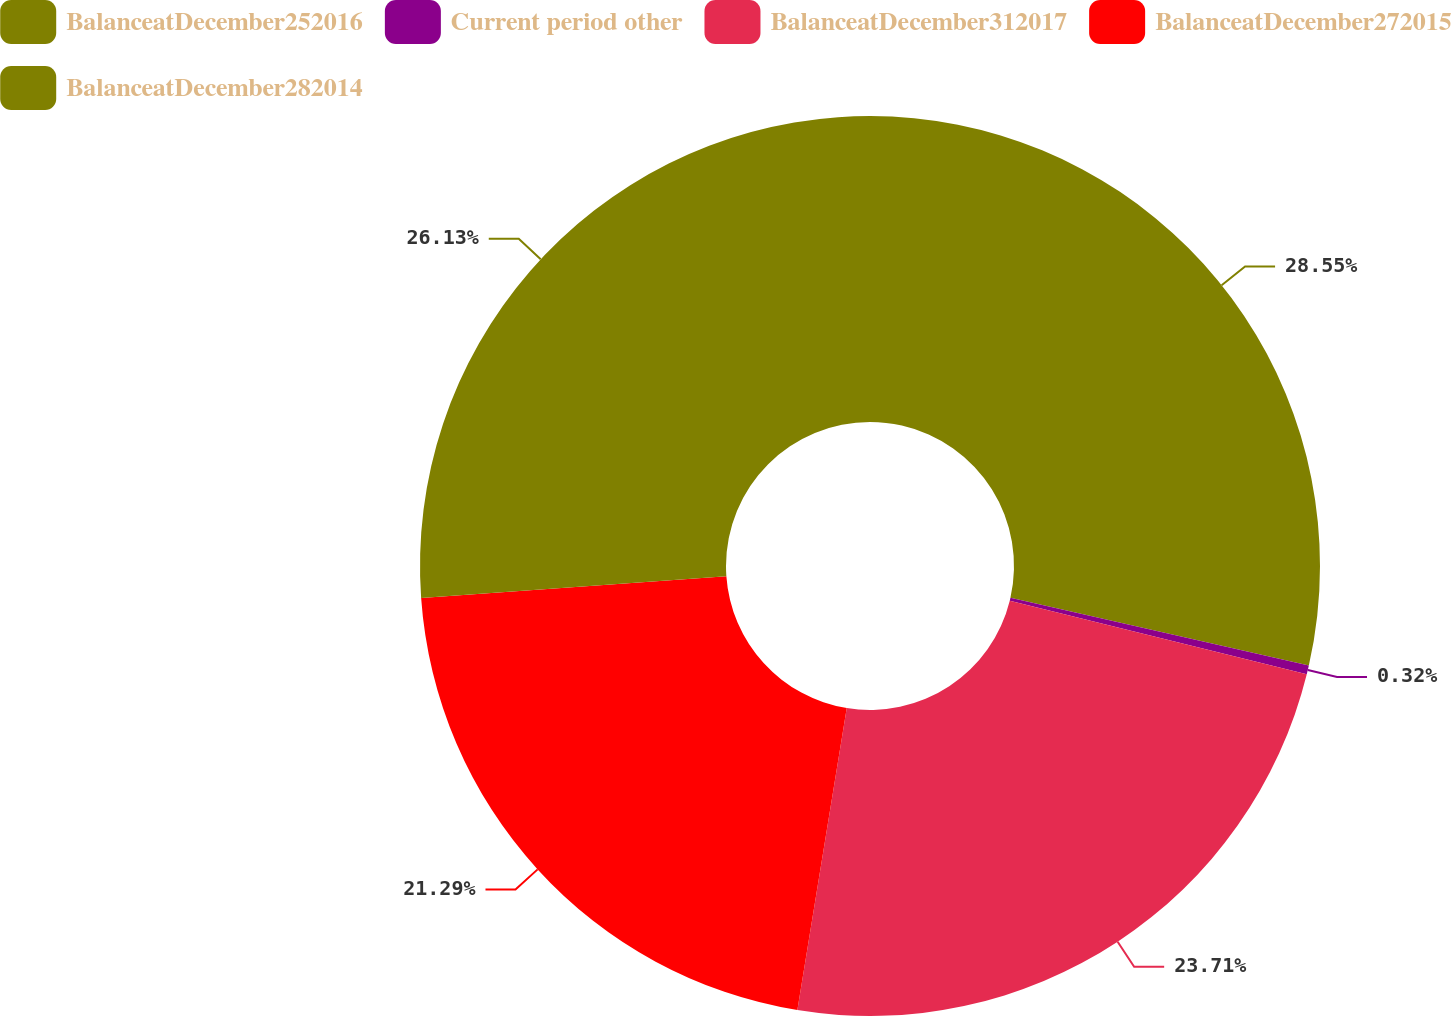Convert chart. <chart><loc_0><loc_0><loc_500><loc_500><pie_chart><fcel>BalanceatDecember252016<fcel>Current period other<fcel>BalanceatDecember312017<fcel>BalanceatDecember272015<fcel>BalanceatDecember282014<nl><fcel>28.55%<fcel>0.32%<fcel>23.71%<fcel>21.29%<fcel>26.13%<nl></chart> 